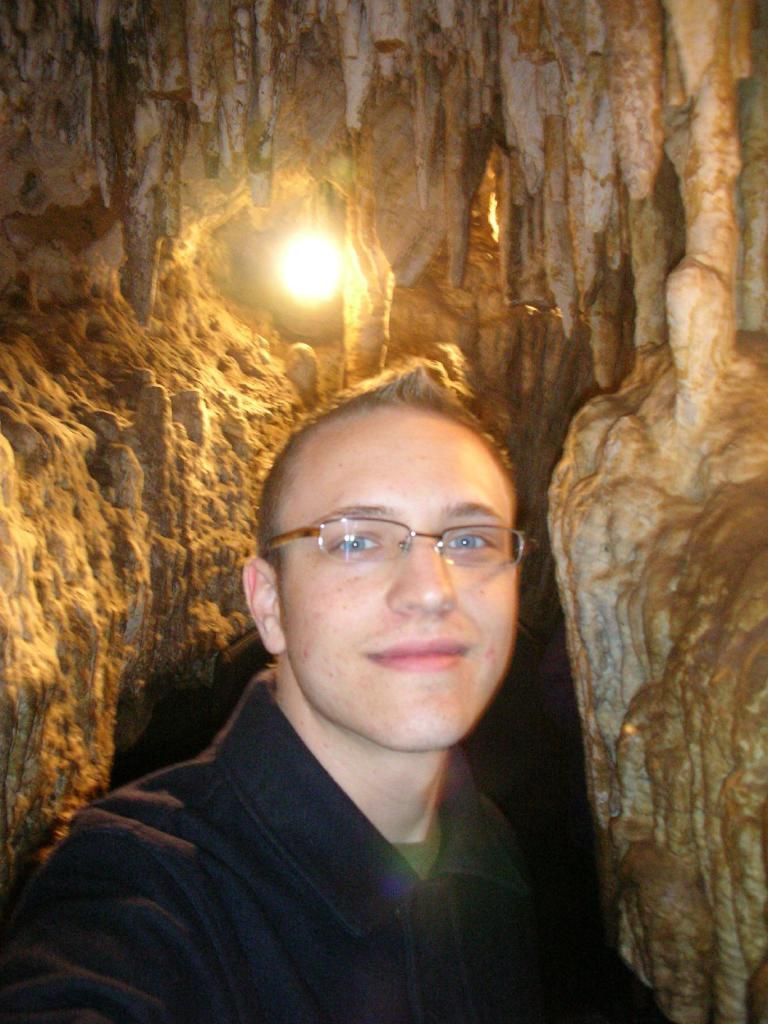Who or what is present in the image? There is a person in the image. What is the person wearing? The person is wearing a black dress. Can you describe any other elements in the image? There is a light visible in the image, as well as rocks. What type of leather is being used to create the curves in the image? There is no leather or curves present in the image. 